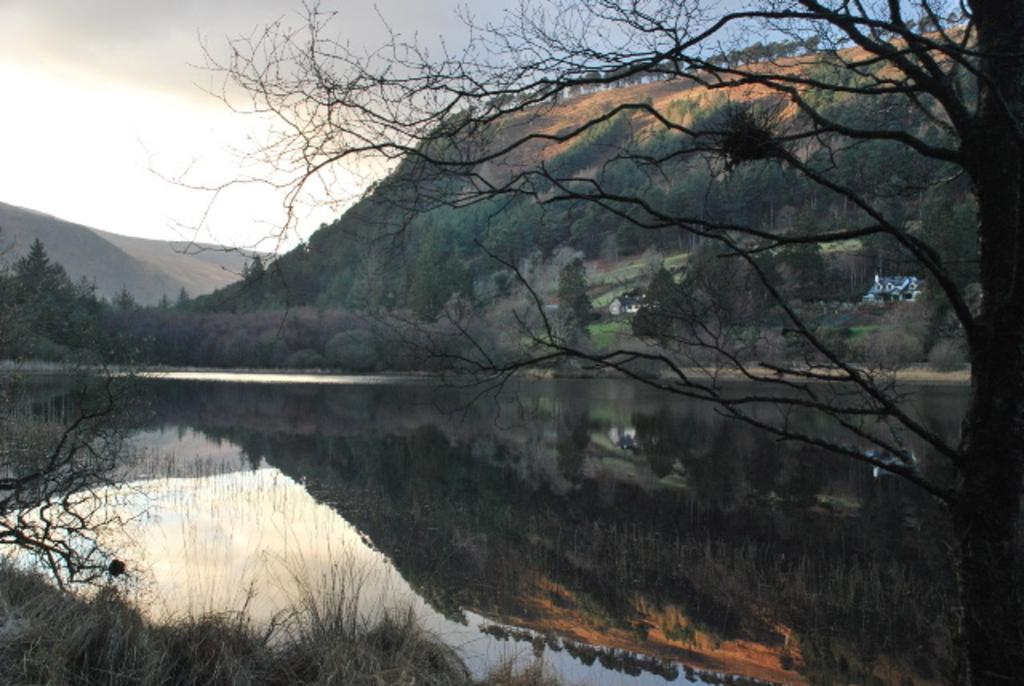What is the primary element in the image? There is water in the image. What type of vegetation can be seen in the image? Dry grass is present in the image. What other natural features are visible in the image? Trees and hills are visible in the image. What structure can be seen in the background of the image? There is a house in the background of the image. What is visible at the top of the image? The sky is visible at the top of the image. How far away is the father from the kettle in the image? There is no father or kettle present in the image. What type of distance can be measured between the trees and the hills in the image? The provided facts do not include any information about the distance between the trees and the hills, so it cannot be determined from the image. 